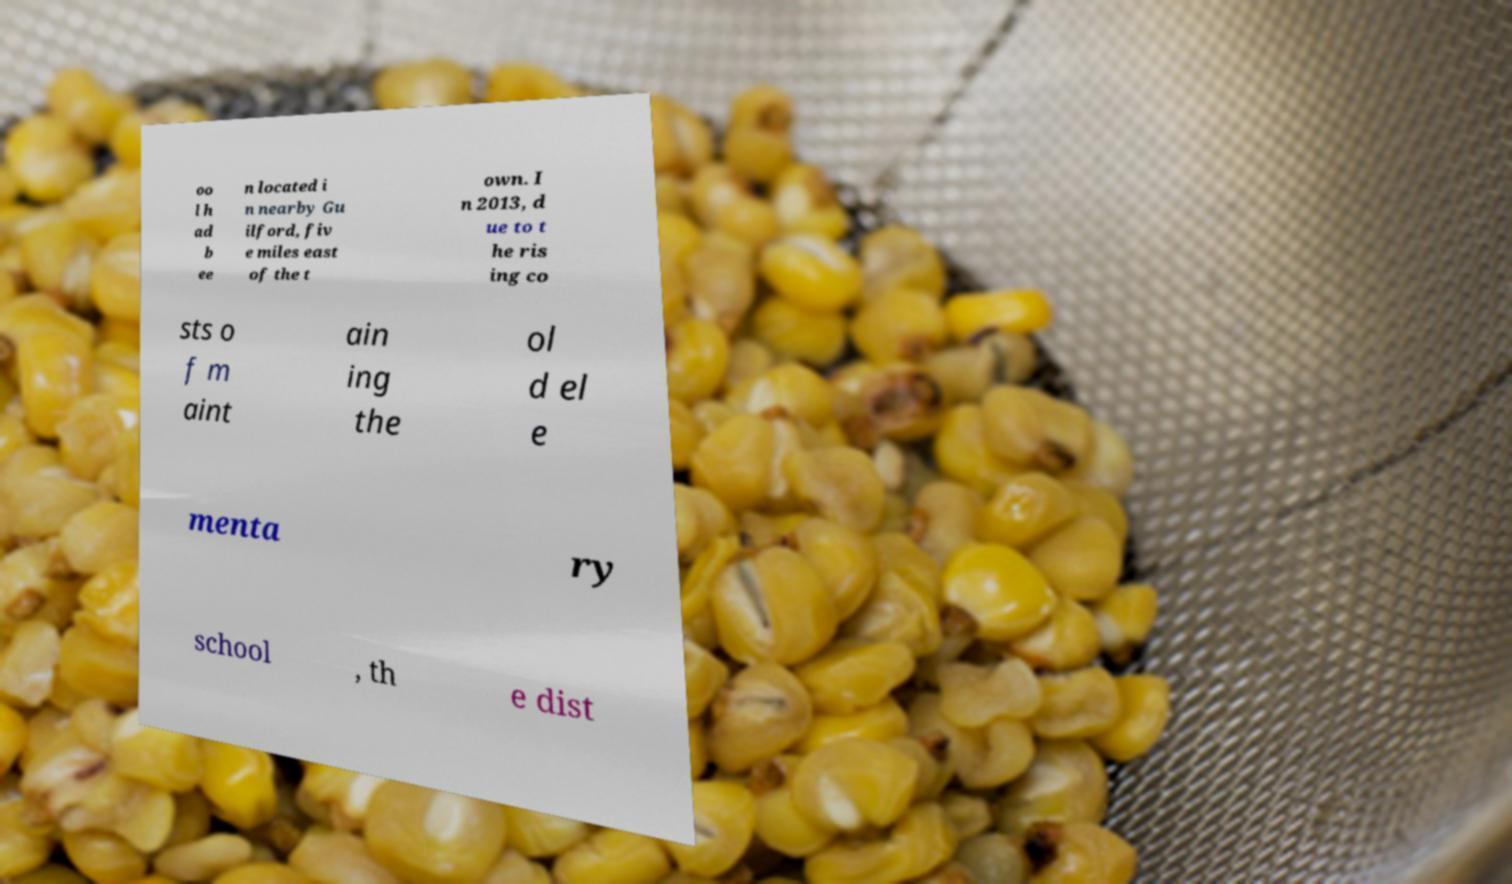For documentation purposes, I need the text within this image transcribed. Could you provide that? oo l h ad b ee n located i n nearby Gu ilford, fiv e miles east of the t own. I n 2013, d ue to t he ris ing co sts o f m aint ain ing the ol d el e menta ry school , th e dist 